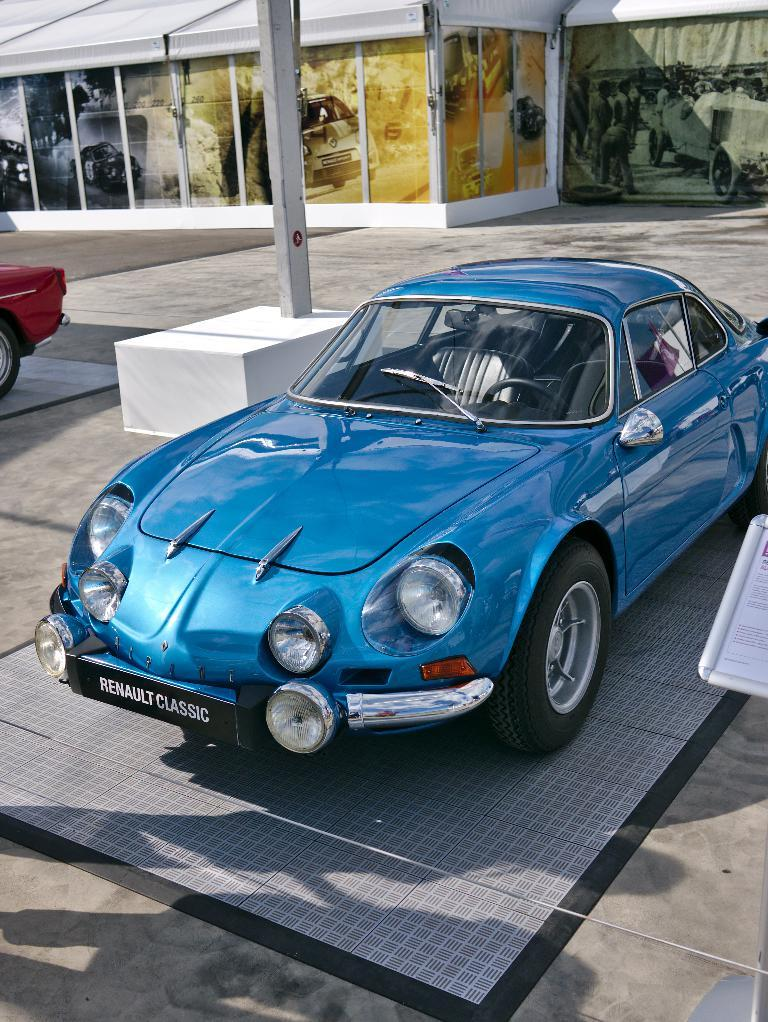What color is the car in the foreground of the image? The car in the foreground of the image is blue. Can you describe the location of the other car in the image? There is a red car on the left side of the image. What type of cork can be seen in the image? There is no cork present in the image; it features two cars, a blue one in the foreground and a red one on the left side. Is there a box visible in the image? No, there is no box present in the image. 